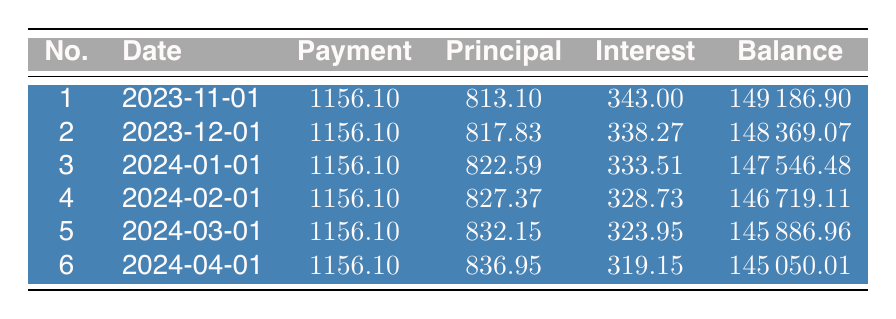What is the payment amount for the first installment? The first installment payment amount is listed directly in the table under the "Payment" column for payment number 1, which is 1156.10.
Answer: 1156.10 How much principal is paid off in the second payment? Looking at the table, the principal amount for the second payment, which is listed under the "Principal" column for payment number 2, is 817.83.
Answer: 817.83 What is the total amount of interest paid in the first three payments? To find the total interest for the first three payments, we add the interest amounts from those payments: 343.00 + 338.27 + 333.51 = 1014.78.
Answer: 1014.78 Is the total amount paid in the first payment greater than the total amount paid in the second payment? Since both payments are the same, 1156.10, the statement is false as they are equal.
Answer: No What is the remaining balance after the fifth payment? From the table, we see that the remaining balance after the fifth payment, found in the "Balance" column for payment number 5, is 145886.96.
Answer: 145886.96 How much did the principal increase from the first payment to the sixth payment? The principal for the first payment is 813.10 and for the sixth payment is 836.95. The difference is calculated as 836.95 - 813.10 = 23.85.
Answer: 23.85 What is the average monthly payment amount over the first six months? The payment amount is constant at 1156.10 for each of the first six months. Hence, the average monthly payment is simply 1156.10.
Answer: 1156.10 How many payments have a principal amount greater than 820? There are three payments with principal amounts greater than 820: payment numbers 3 (822.59), 4 (827.37), and 5 (832.15). Thus, the count is three.
Answer: 3 What is the total remaining balance after the first month? The remaining balance after the first month (payment number 1) is directly recorded in the table, which is 149186.90.
Answer: 149186.90 